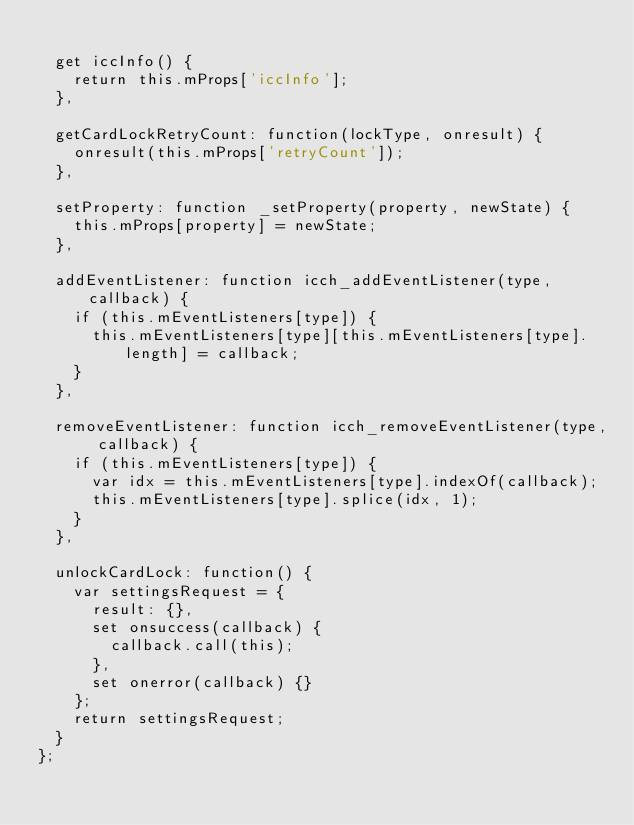Convert code to text. <code><loc_0><loc_0><loc_500><loc_500><_JavaScript_>
  get iccInfo() {
    return this.mProps['iccInfo'];
  },

  getCardLockRetryCount: function(lockType, onresult) {
    onresult(this.mProps['retryCount']);
  },

  setProperty: function _setProperty(property, newState) {
    this.mProps[property] = newState;
  },

  addEventListener: function icch_addEventListener(type, callback) {
    if (this.mEventListeners[type]) {
      this.mEventListeners[type][this.mEventListeners[type].length] = callback;
    }
  },

  removeEventListener: function icch_removeEventListener(type, callback) {
    if (this.mEventListeners[type]) {
      var idx = this.mEventListeners[type].indexOf(callback);
      this.mEventListeners[type].splice(idx, 1);
    }
  },

  unlockCardLock: function() {
    var settingsRequest = {
      result: {},
      set onsuccess(callback) {
        callback.call(this);
      },
      set onerror(callback) {}
    };
    return settingsRequest;
  }
};
</code> 